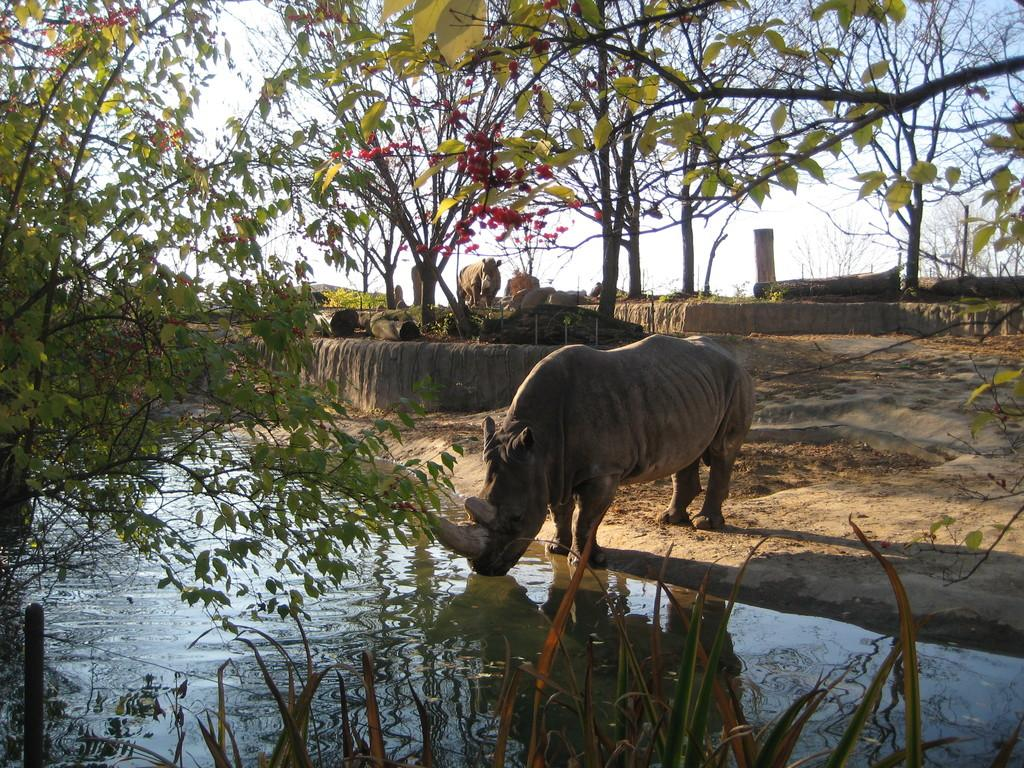What is there is an animal in the image, what is it doing? The animal in the image is drinking water. Can you describe the other animal in the background? Unfortunately, the facts provided do not give enough information to describe the other animal in the background. What type of vegetation can be seen in the background? There are trees with green color in the background. What is the color of the sky in the image? The sky is in white color. What is the texture of the water that the animal is drinking? The facts provided do not give enough information about the texture of the water. 